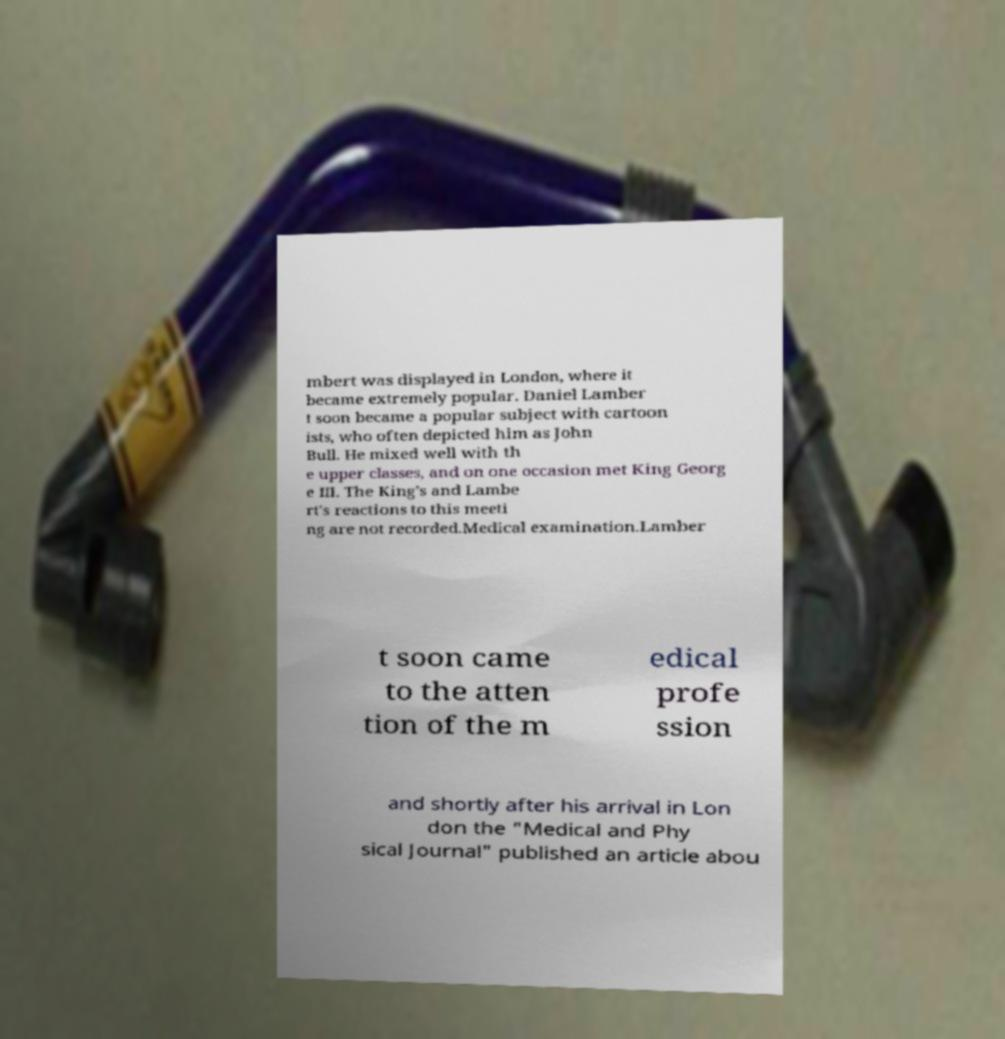Can you read and provide the text displayed in the image?This photo seems to have some interesting text. Can you extract and type it out for me? mbert was displayed in London, where it became extremely popular. Daniel Lamber t soon became a popular subject with cartoon ists, who often depicted him as John Bull. He mixed well with th e upper classes, and on one occasion met King Georg e III. The King's and Lambe rt's reactions to this meeti ng are not recorded.Medical examination.Lamber t soon came to the atten tion of the m edical profe ssion and shortly after his arrival in Lon don the "Medical and Phy sical Journal" published an article abou 